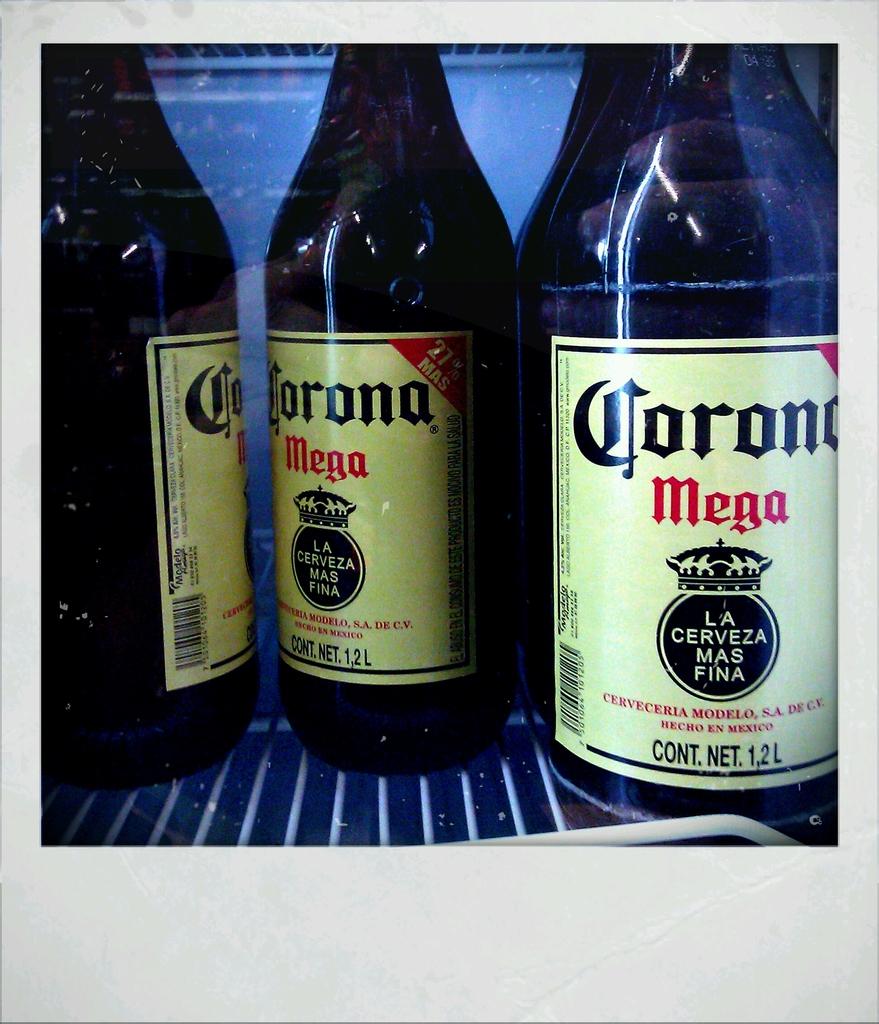What is the beer brand on the right?
Keep it short and to the point. Corona. 